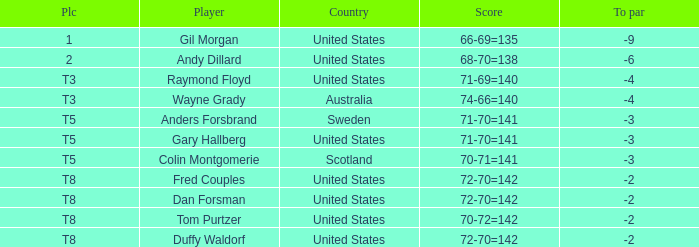What is the T8 Place Player? Fred Couples, Dan Forsman, Tom Purtzer, Duffy Waldorf. 